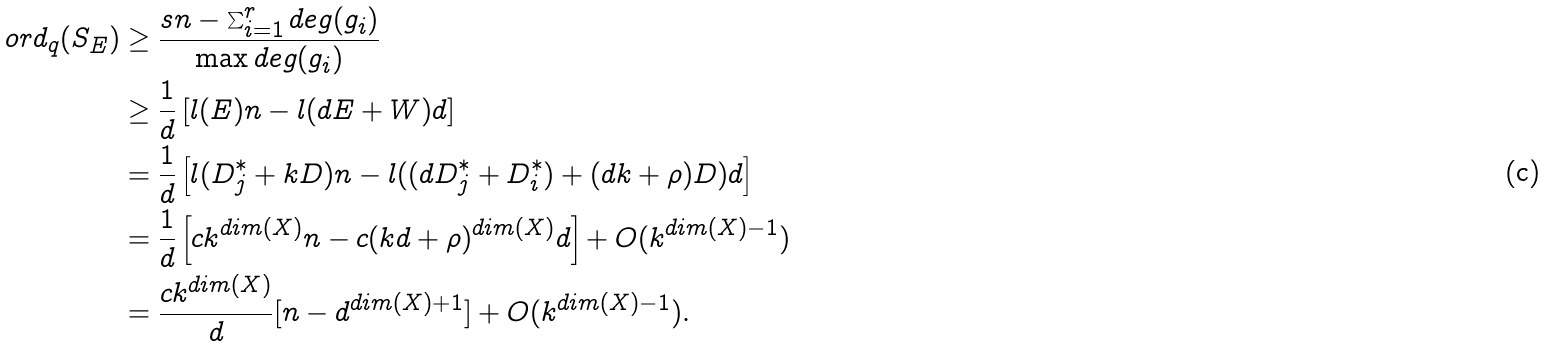Convert formula to latex. <formula><loc_0><loc_0><loc_500><loc_500>o r d _ { q } ( S _ { E } ) & \geq \frac { s n - \sum _ { i = 1 } ^ { r } d e g ( g _ { i } ) } { \max d e g ( g _ { i } ) } \\ & \geq \frac { 1 } { d } \left [ l ( E ) n - l ( d E + W ) d \right ] \\ & = \frac { 1 } { d } \left [ l ( D _ { j } ^ { * } + k D ) n - l ( ( d D _ { j } ^ { * } + D _ { i } ^ { * } ) + ( d k + \rho ) D ) d \right ] \\ & = \frac { 1 } { d } \left [ c k ^ { d i m ( X ) } n - c ( k d + \rho ) ^ { d i m ( X ) } d \right ] + O ( k ^ { d i m ( X ) - 1 } ) \\ & = \frac { c k ^ { d i m ( X ) } } { d } [ n - d ^ { d i m ( X ) + 1 } ] + O ( k ^ { d i m ( X ) - 1 } ) .</formula> 